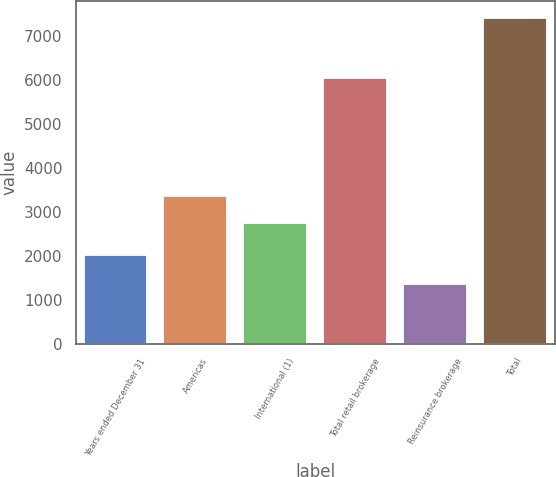<chart> <loc_0><loc_0><loc_500><loc_500><bar_chart><fcel>Years ended December 31<fcel>Americas<fcel>International (1)<fcel>Total retail brokerage<fcel>Reinsurance brokerage<fcel>Total<nl><fcel>2015<fcel>3354.4<fcel>2750<fcel>6044<fcel>1361<fcel>7405<nl></chart> 